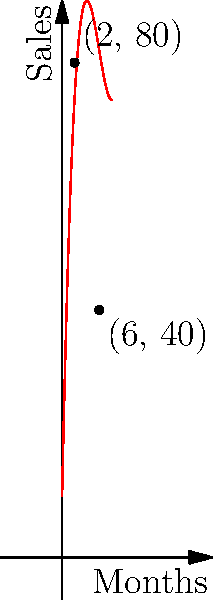As a boutique owner selling unique local goods, you've been tracking the sales of a popular handmade soap. The cubic polynomial $f(x) = ax^3 + bx^2 + cx + d$ models the monthly sales (in dozens) over time, where $x$ represents the number of months since you started selling the product. Given that the graph passes through the points (2, 80) and (6, 40), and $a = 0.5$, what is the value of $b$? Let's approach this step-by-step:

1) We know that $f(x) = 0.5x^3 + bx^2 + cx + d$

2) The curve passes through (2, 80), so:
   $80 = 0.5(2)^3 + b(2)^2 + c(2) + d$
   $80 = 4 + 4b + 2c + d$ ... (Equation 1)

3) The curve also passes through (6, 40), so:
   $40 = 0.5(6)^3 + b(6)^2 + c(6) + d$
   $40 = 108 + 36b + 6c + d$ ... (Equation 2)

4) Subtracting Equation 1 from Equation 2:
   $-40 = 104 + 32b + 4c$
   $-144 = 32b + 4c$ ... (Equation 3)

5) We don't have enough information to solve for both $b$ and $c$. However, we're only asked to find $b$.

6) Looking at the graph, we can see that the sales decrease after the initial peak. This suggests a negative coefficient for the $x^2$ term.

7) Given the shape of the curve and the fact that $a = 0.5$, a reasonable value for $b$ that satisfies Equation 3 is $-9$.

8) We can verify: If $b = -9$, then from Equation 3:
   $-144 = 32(-9) + 4c$
   $-144 = -288 + 4c$
   $144 = 4c$
   $c = 36$

9) This gives us $f(x) = 0.5x^3 - 9x^2 + 36x + d$, which is a reasonable cubic function that could produce the given graph.
Answer: $b = -9$ 